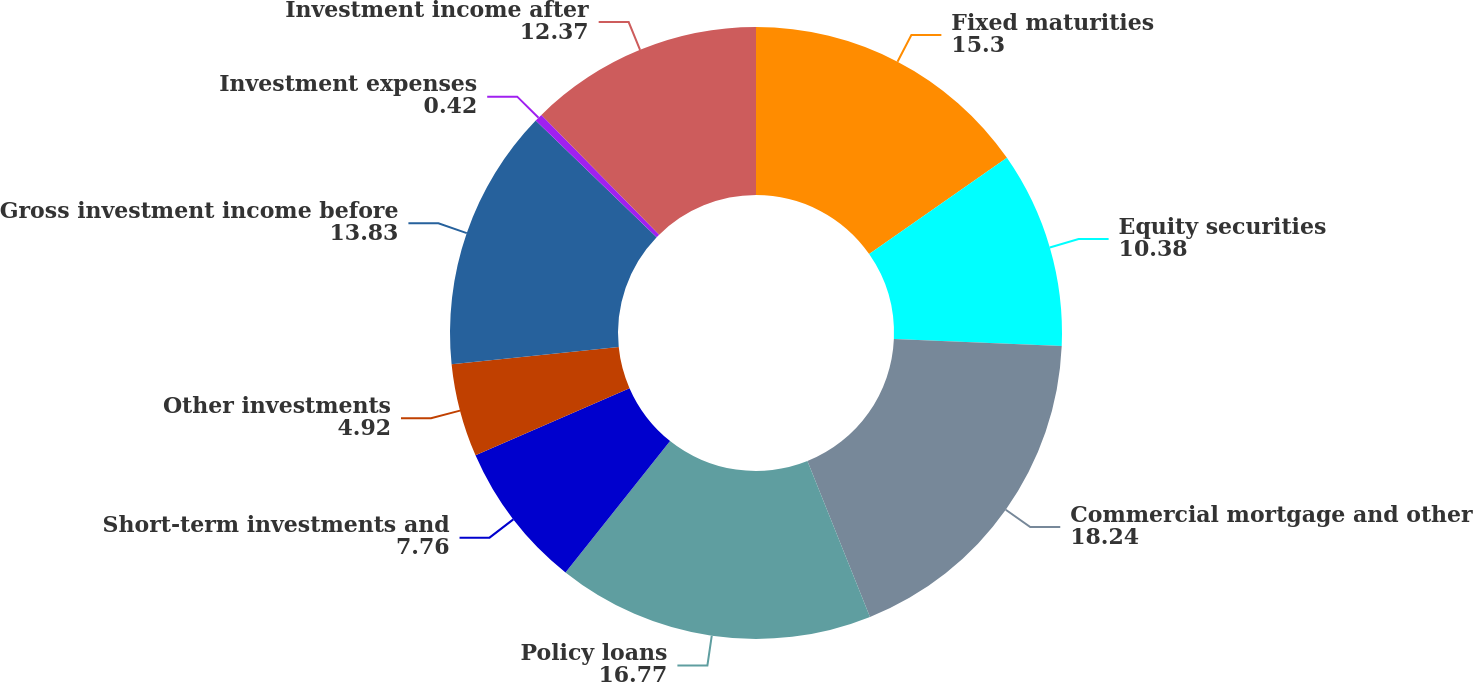Convert chart. <chart><loc_0><loc_0><loc_500><loc_500><pie_chart><fcel>Fixed maturities<fcel>Equity securities<fcel>Commercial mortgage and other<fcel>Policy loans<fcel>Short-term investments and<fcel>Other investments<fcel>Gross investment income before<fcel>Investment expenses<fcel>Investment income after<nl><fcel>15.3%<fcel>10.38%<fcel>18.24%<fcel>16.77%<fcel>7.76%<fcel>4.92%<fcel>13.83%<fcel>0.42%<fcel>12.37%<nl></chart> 